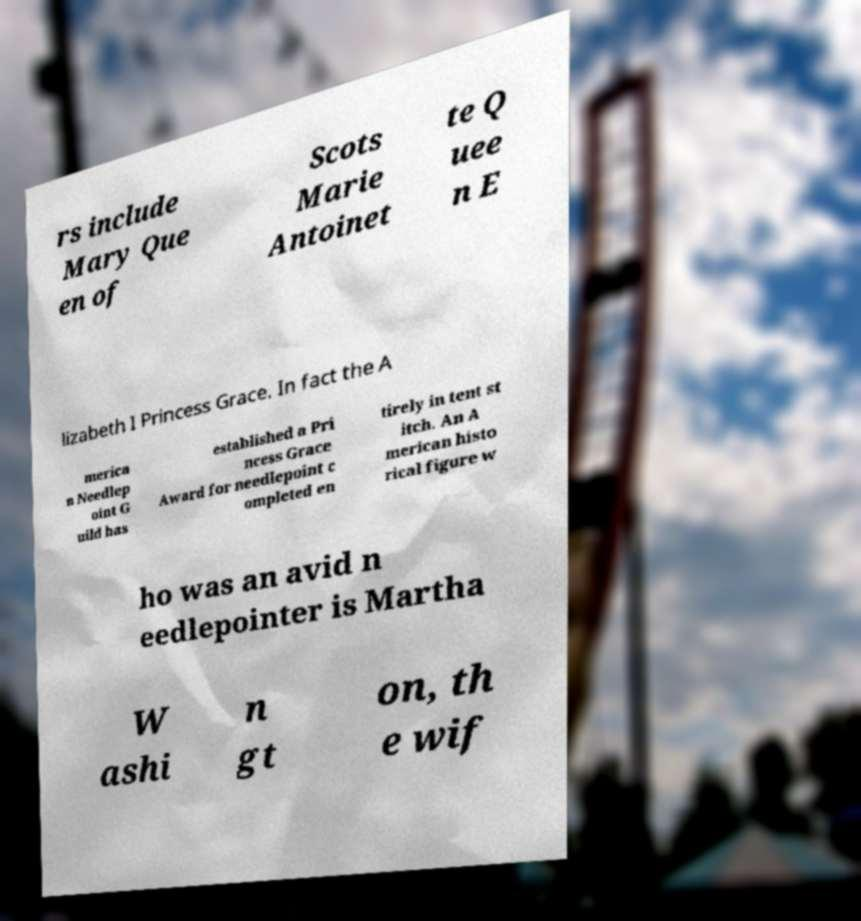For documentation purposes, I need the text within this image transcribed. Could you provide that? rs include Mary Que en of Scots Marie Antoinet te Q uee n E lizabeth I Princess Grace. In fact the A merica n Needlep oint G uild has established a Pri ncess Grace Award for needlepoint c ompleted en tirely in tent st itch. An A merican histo rical figure w ho was an avid n eedlepointer is Martha W ashi n gt on, th e wif 